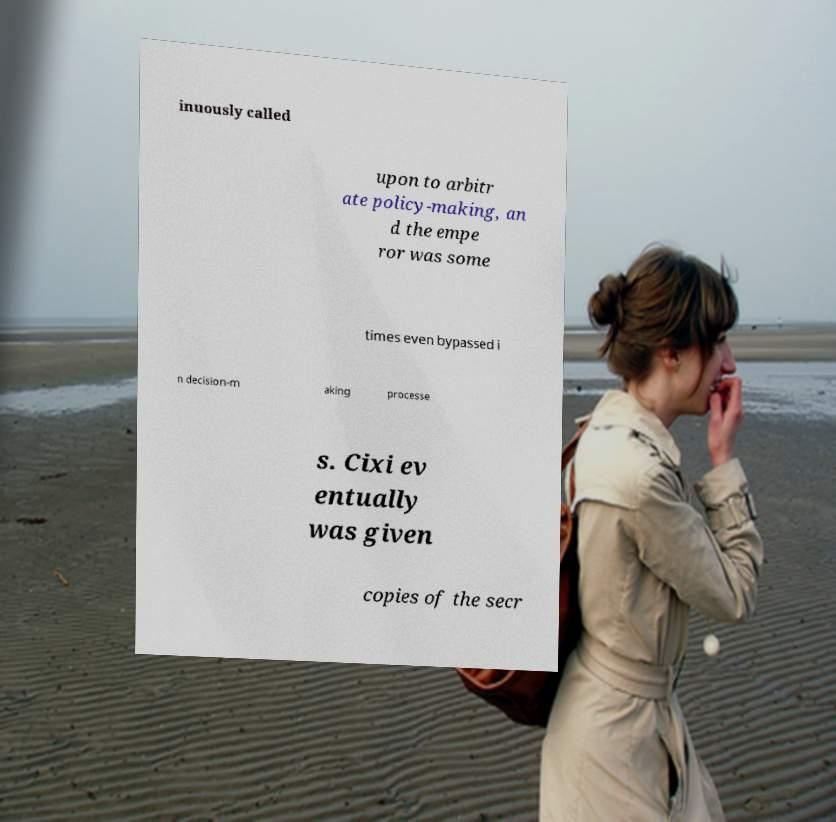Please identify and transcribe the text found in this image. inuously called upon to arbitr ate policy-making, an d the empe ror was some times even bypassed i n decision-m aking processe s. Cixi ev entually was given copies of the secr 